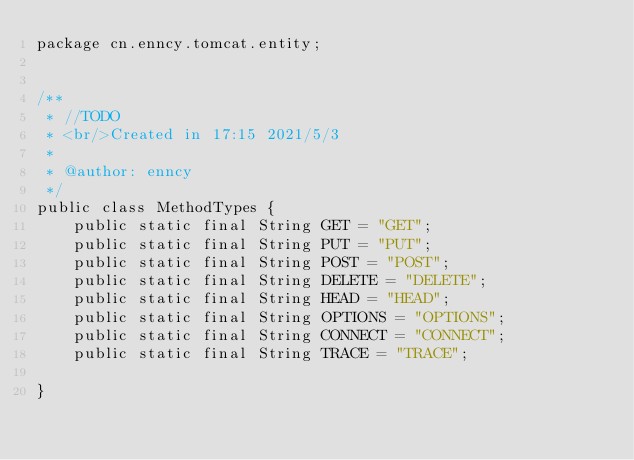Convert code to text. <code><loc_0><loc_0><loc_500><loc_500><_Java_>package cn.enncy.tomcat.entity;


/**
 * //TODO
 * <br/>Created in 17:15 2021/5/3
 *
 * @author: enncy
 */
public class MethodTypes {
    public static final String GET = "GET";
    public static final String PUT = "PUT";
    public static final String POST = "POST";
    public static final String DELETE = "DELETE";
    public static final String HEAD = "HEAD";
    public static final String OPTIONS = "OPTIONS";
    public static final String CONNECT = "CONNECT";
    public static final String TRACE = "TRACE";

}
</code> 